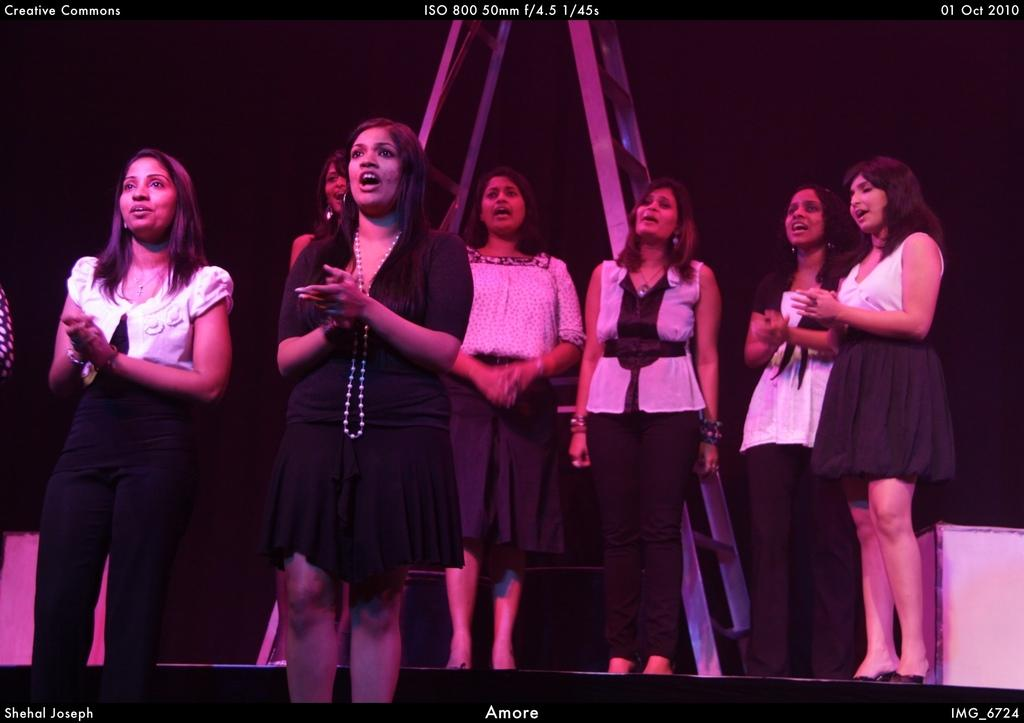What type of people can be seen in the image? There are women standing in the image. What object is present in the image that might be used for climbing or reaching higher places? There is a ladder in the image. What type of brass instrument can be seen being played by the women in the image? There is no brass instrument present in the image; it only features women and a ladder. 